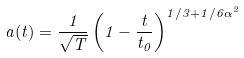Convert formula to latex. <formula><loc_0><loc_0><loc_500><loc_500>a ( t ) = \frac { 1 } { \sqrt { T } } \left ( 1 - \frac { t } { t _ { 0 } } \right ) ^ { 1 / 3 + 1 / 6 \alpha ^ { 2 } }</formula> 